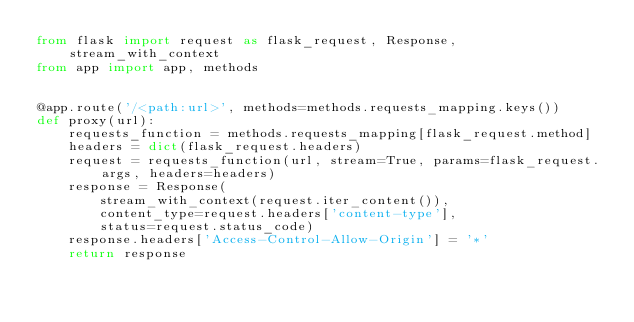<code> <loc_0><loc_0><loc_500><loc_500><_Python_>from flask import request as flask_request, Response, stream_with_context
from app import app, methods


@app.route('/<path:url>', methods=methods.requests_mapping.keys())
def proxy(url):
    requests_function = methods.requests_mapping[flask_request.method]
    headers = dict(flask_request.headers)
    request = requests_function(url, stream=True, params=flask_request.args, headers=headers)
    response = Response(
        stream_with_context(request.iter_content()),
        content_type=request.headers['content-type'],
        status=request.status_code)
    response.headers['Access-Control-Allow-Origin'] = '*'
    return response
</code> 